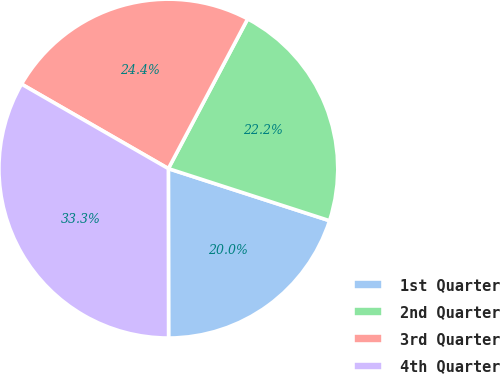Convert chart to OTSL. <chart><loc_0><loc_0><loc_500><loc_500><pie_chart><fcel>1st Quarter<fcel>2nd Quarter<fcel>3rd Quarter<fcel>4th Quarter<nl><fcel>20.0%<fcel>22.22%<fcel>24.44%<fcel>33.33%<nl></chart> 